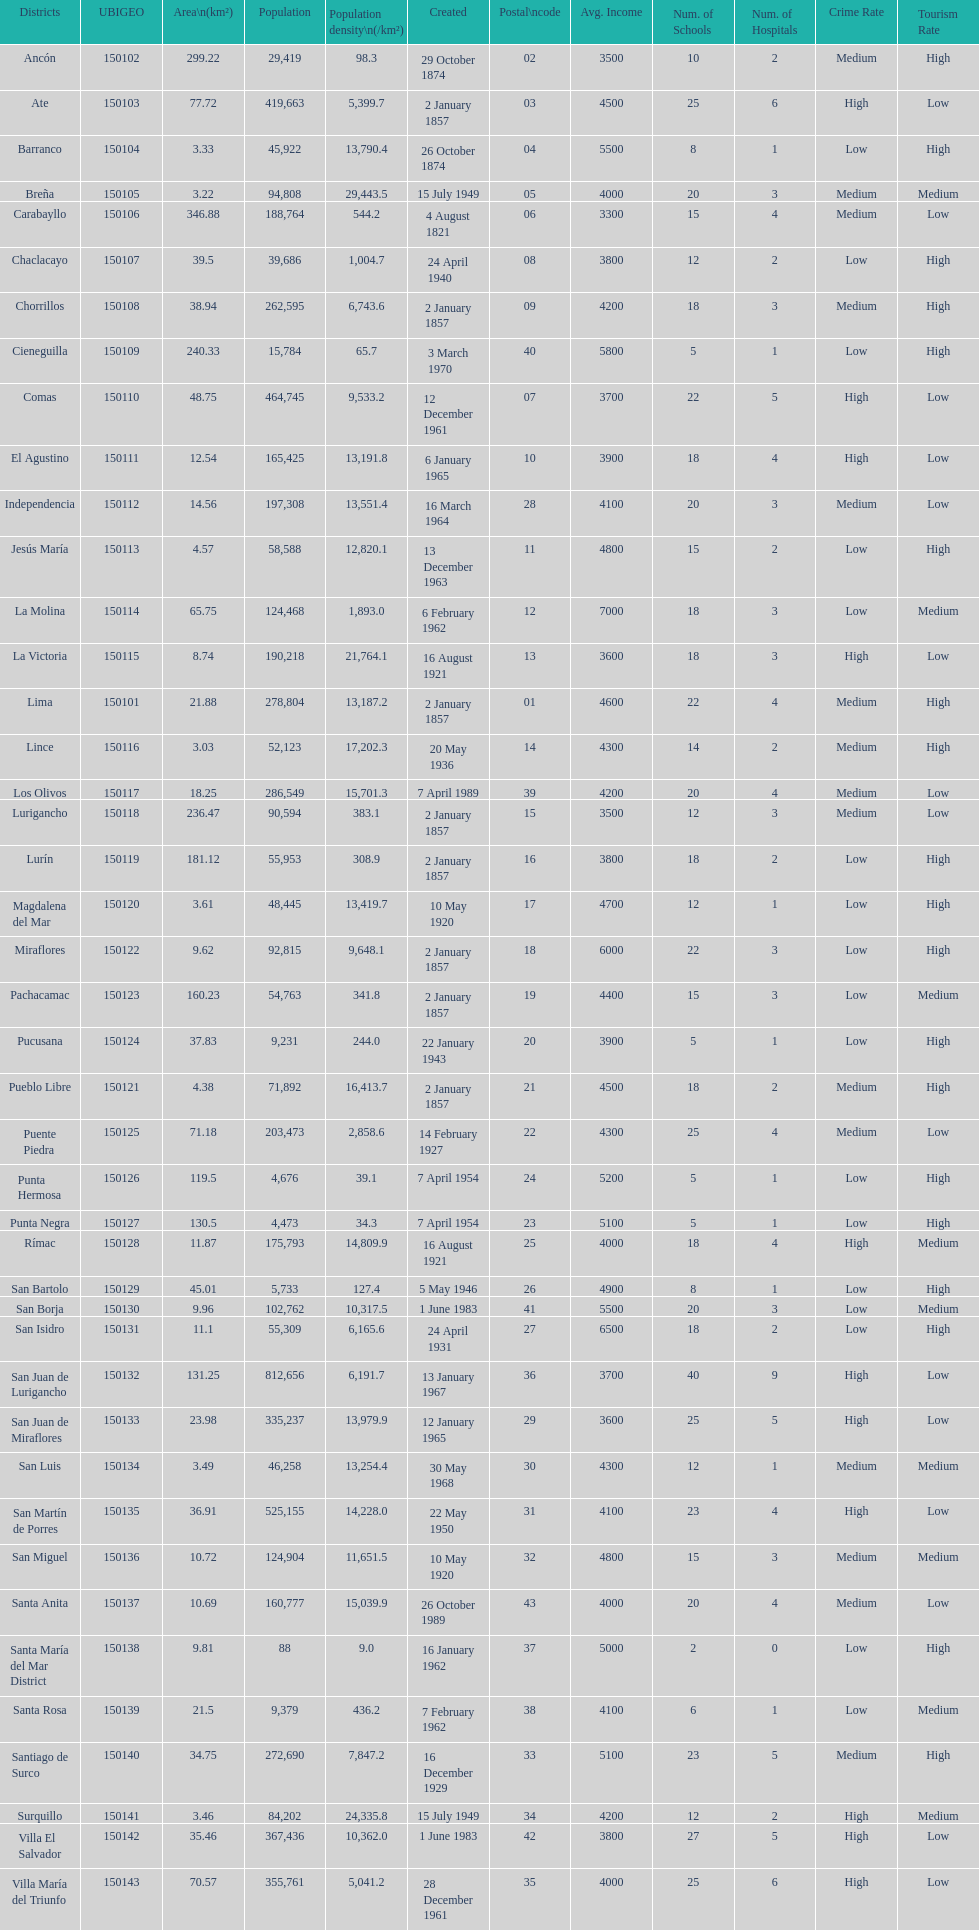How many districts have more than 100,000 people in this city? 21. 